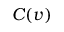Convert formula to latex. <formula><loc_0><loc_0><loc_500><loc_500>C ( v )</formula> 